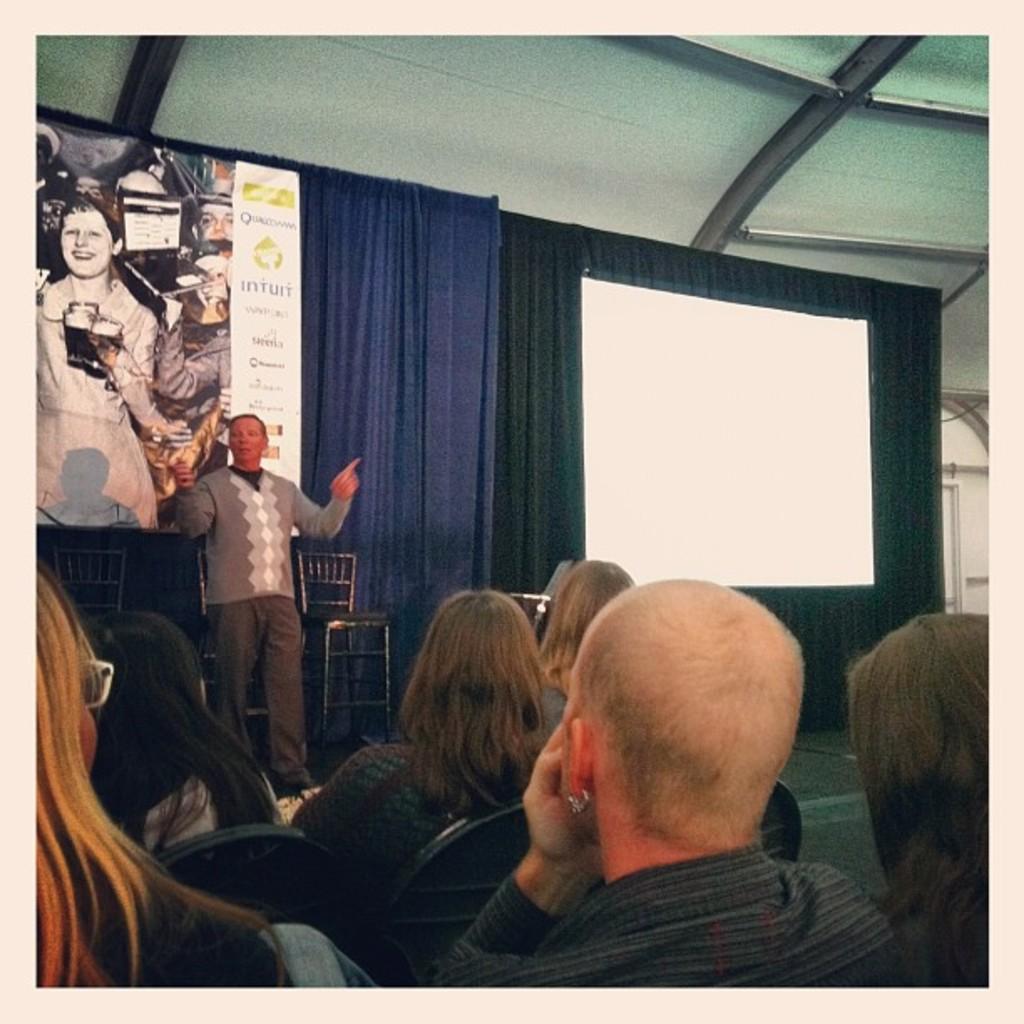Could you give a brief overview of what you see in this image? In this picture there is a man wearing grey color sweater standing and explaining something. In the front we can see a group of men and women sitting on the chair and listening to him. Behind there is a blue curtain and a white color poster. 